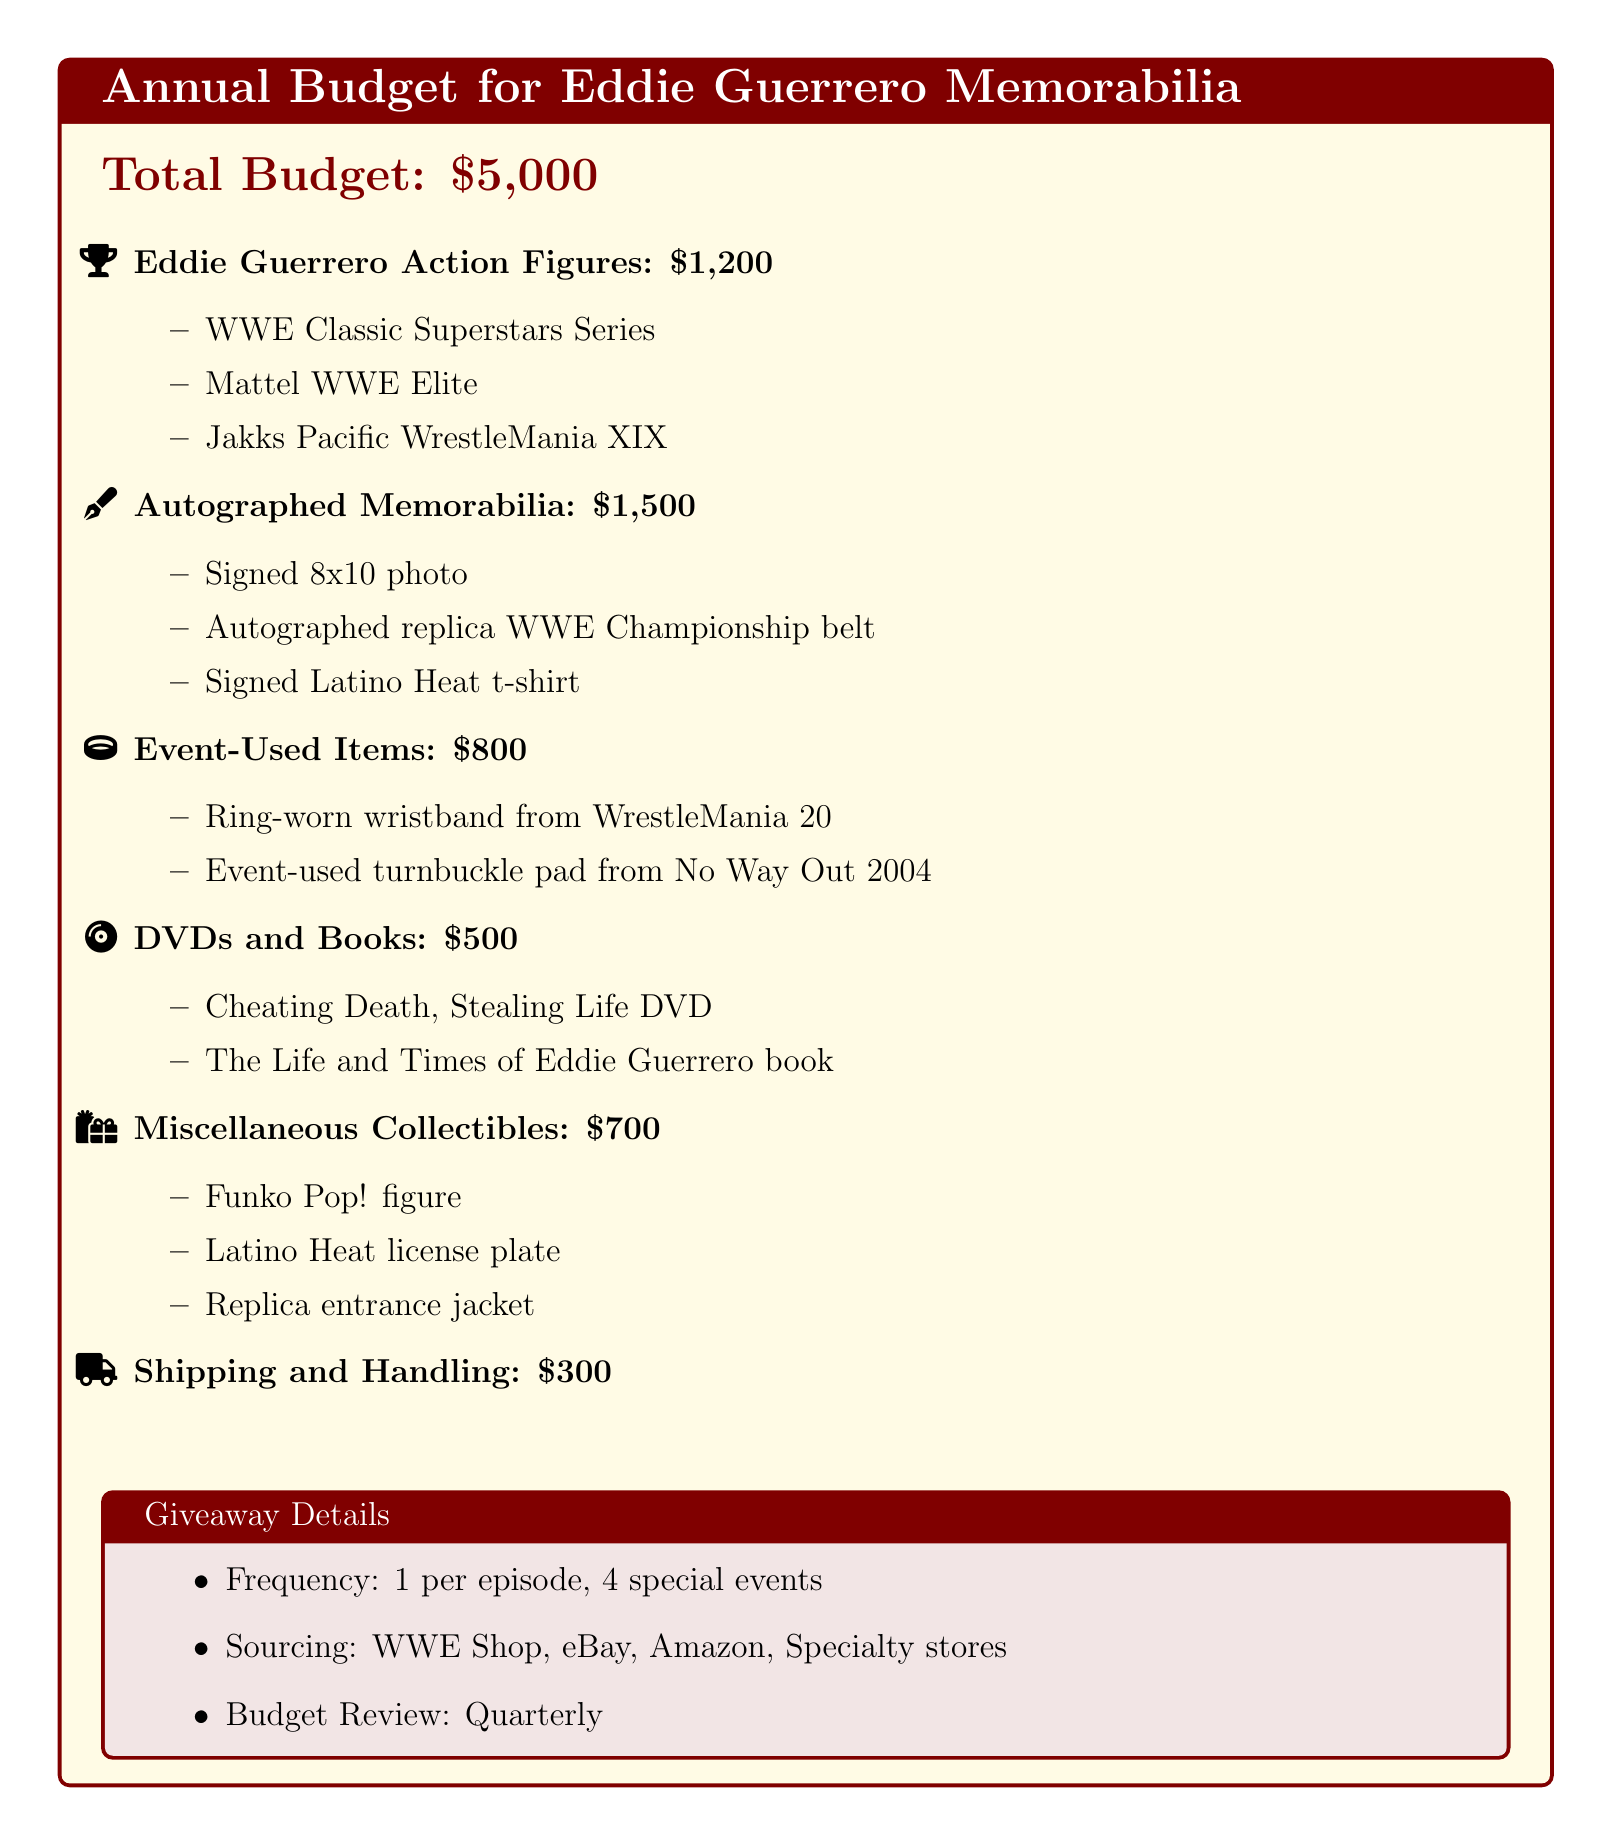What is the total budget? The total budget for purchasing memorabilia is stated at the beginning of the document.
Answer: $5,000 How much is allocated for autographed memorabilia? The document specifies the budget allocation for autographed memorabilia under a specific section.
Answer: $1,500 What is one of the action figure brands mentioned? The document lists specific brands of Eddie Guerrero action figures as part of the budget.
Answer: Mattel WWE Elite How often are giveaways scheduled? The giveaway frequency is mentioned in a specific section of the document.
Answer: 1 per episode What is the budget for shipping and handling? The document clearly states the budget allocated for shipping and handling expenses.
Answer: $300 What type of event-used item is listed? The document includes specific examples of event-used items in the budget breakdown.
Answer: Ring-worn wristband from WrestleMania 20 What collectible is listed under miscellaneous? The document lists various miscellaneous collectibles as part of the budget allocation.
Answer: Funko Pop! figure What is the budget for DVDs and books? The document provides a specific budget allocation for educational materials related to Eddie Guerrero.
Answer: $500 What is included in the autographed memorabilia category? The document details specific items that are considered autographed memorabilia.
Answer: Signed 8x10 photo 